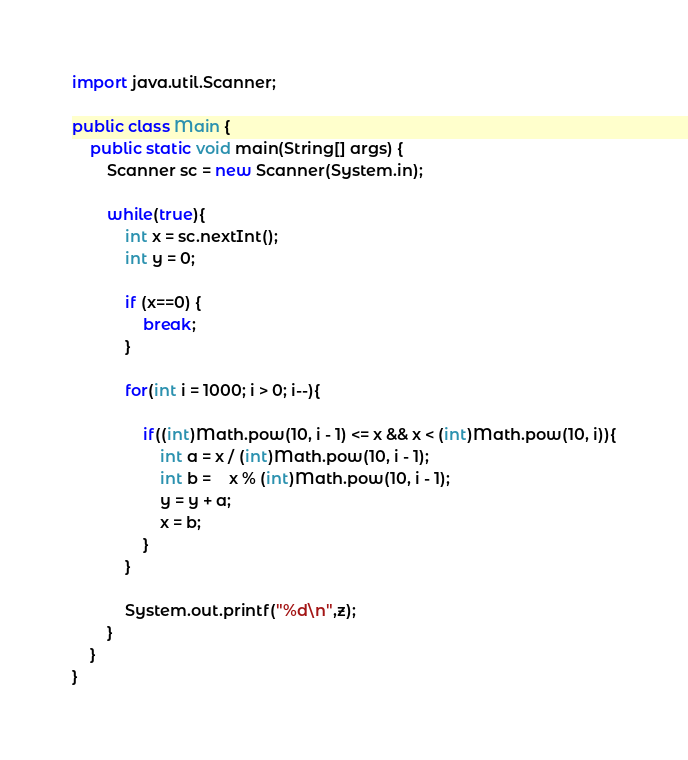<code> <loc_0><loc_0><loc_500><loc_500><_Java_>
import java.util.Scanner;

public class Main {
	public static void main(String[] args) {
		Scanner sc = new Scanner(System.in);

		while(true){
			int x = sc.nextInt();
			int y = 0;

			if (x==0) {
				break;
			}

			for(int i = 1000; i > 0; i--){

				if((int)Math.pow(10, i - 1) <= x && x < (int)Math.pow(10, i)){
					int a = x / (int)Math.pow(10, i - 1);
					int b =	x % (int)Math.pow(10, i - 1);
					y = y + a;
					x = b;
				}
			}

			System.out.printf("%d\n",z);
		}
	}
}</code> 